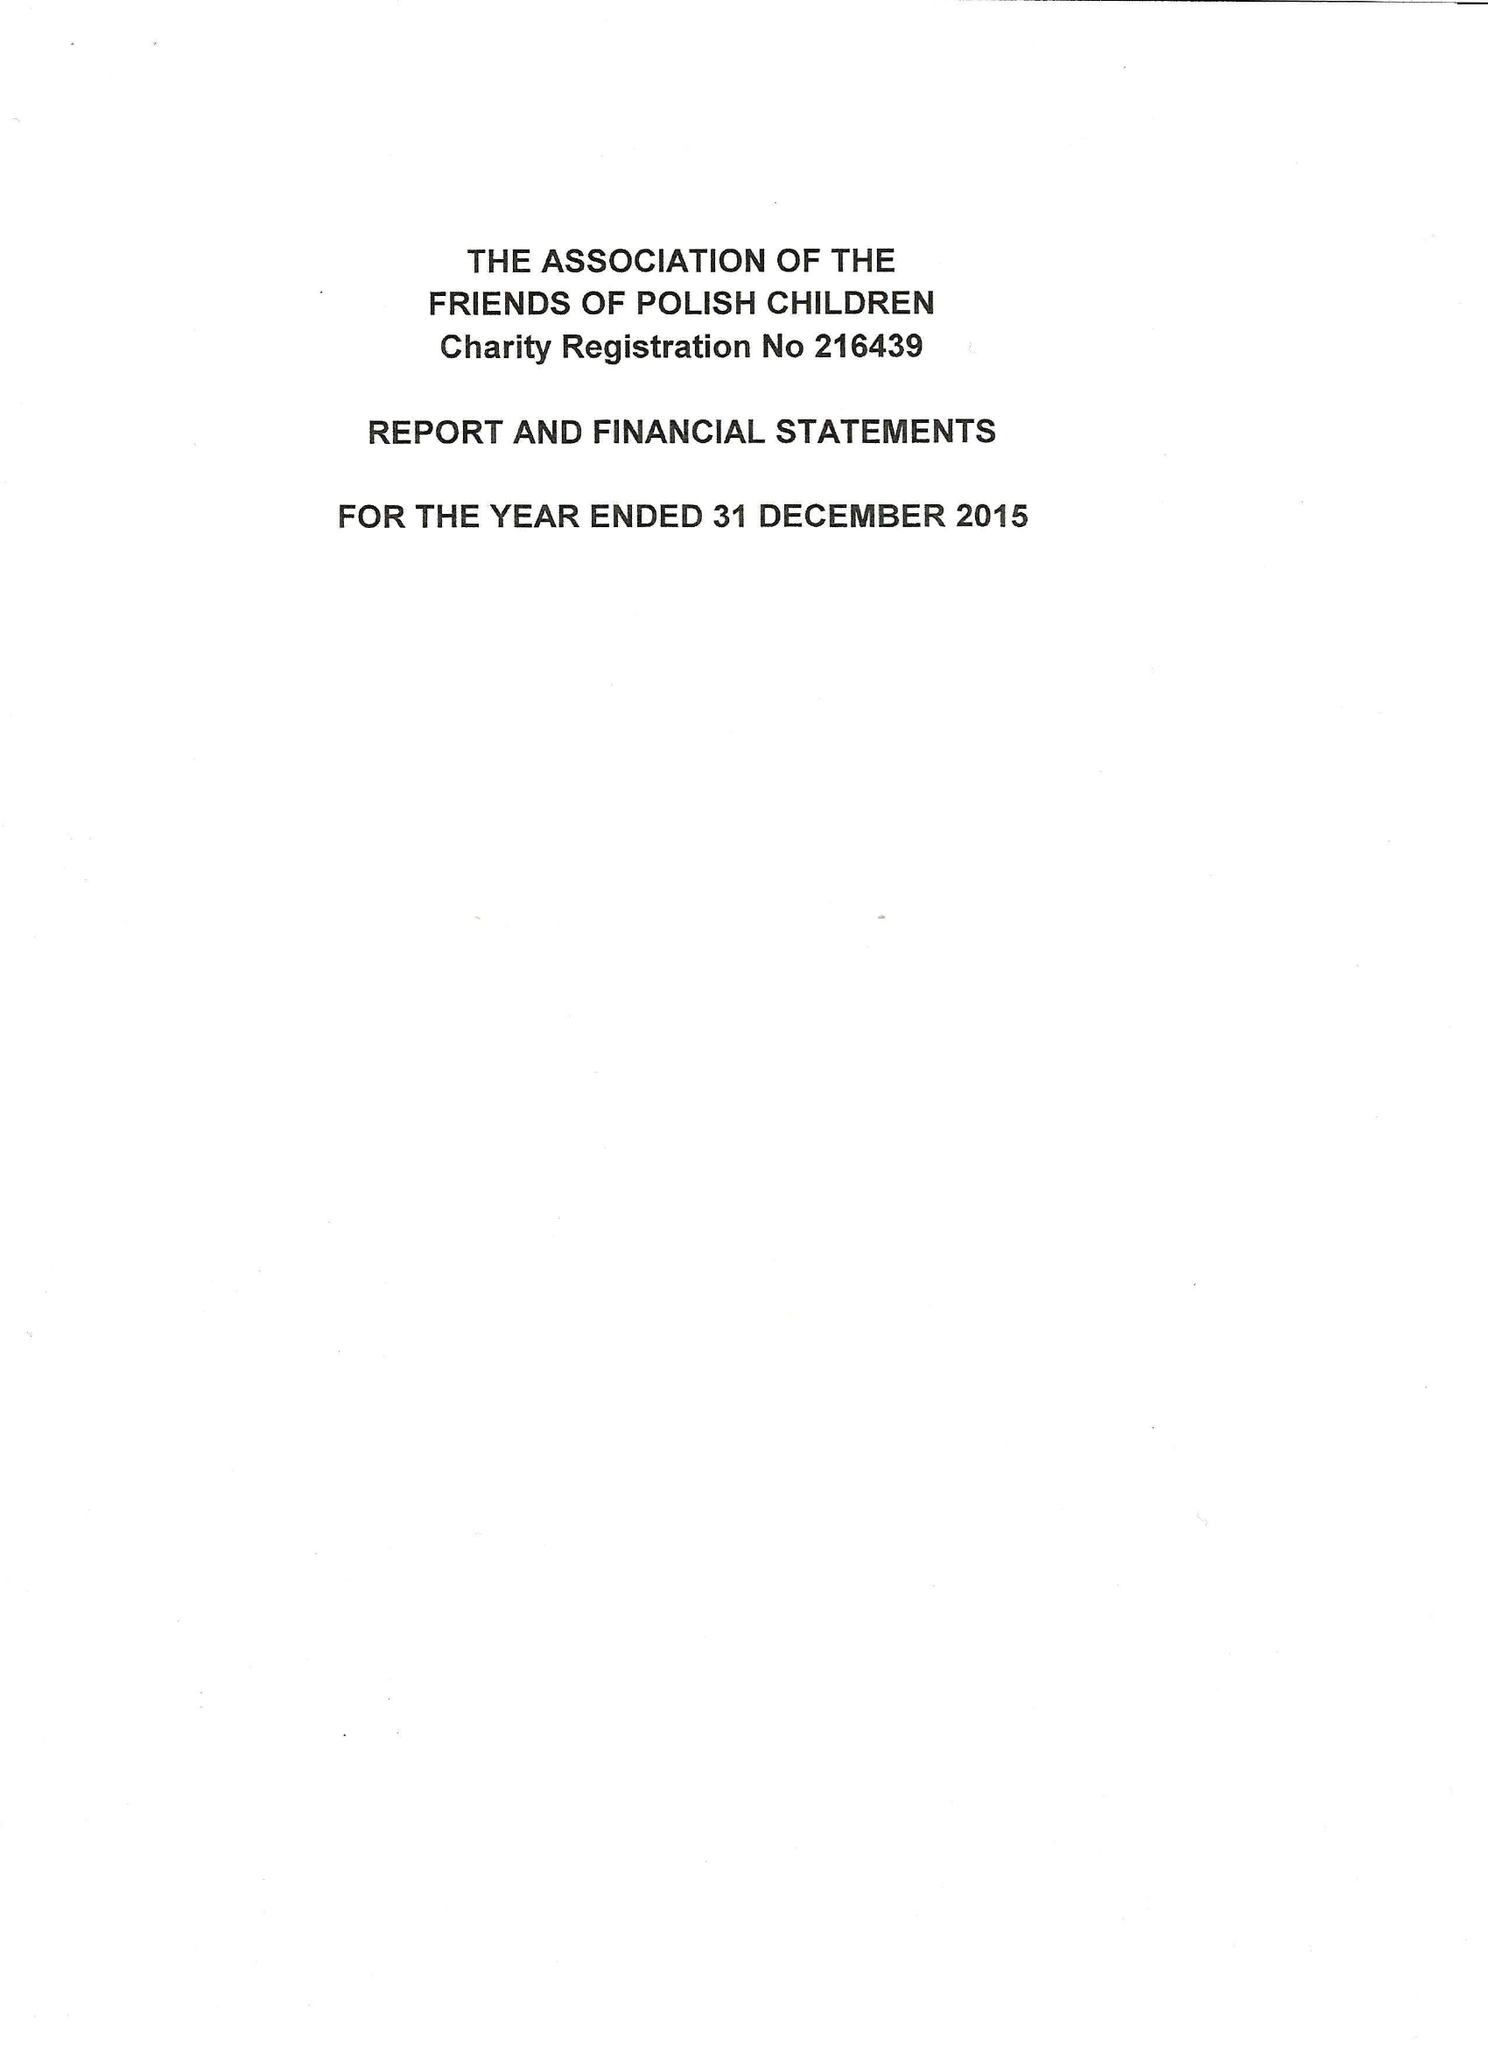What is the value for the address__post_town?
Answer the question using a single word or phrase. LONDON 